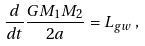<formula> <loc_0><loc_0><loc_500><loc_500>\frac { d } { d t } \frac { G M _ { 1 } M _ { 2 } } { 2 a } = L _ { g w } \, ,</formula> 